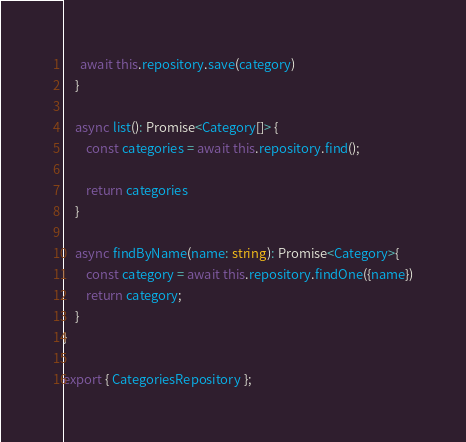Convert code to text. <code><loc_0><loc_0><loc_500><loc_500><_TypeScript_>      await this.repository.save(category)
    }

    async list(): Promise<Category[]> {
        const categories = await this.repository.find();

        return categories
    }

    async findByName(name: string): Promise<Category>{
        const category = await this.repository.findOne({name})
        return category;
    }
}

export { CategoriesRepository };</code> 